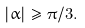<formula> <loc_0><loc_0><loc_500><loc_500>| \alpha | \geq \pi / 3 .</formula> 